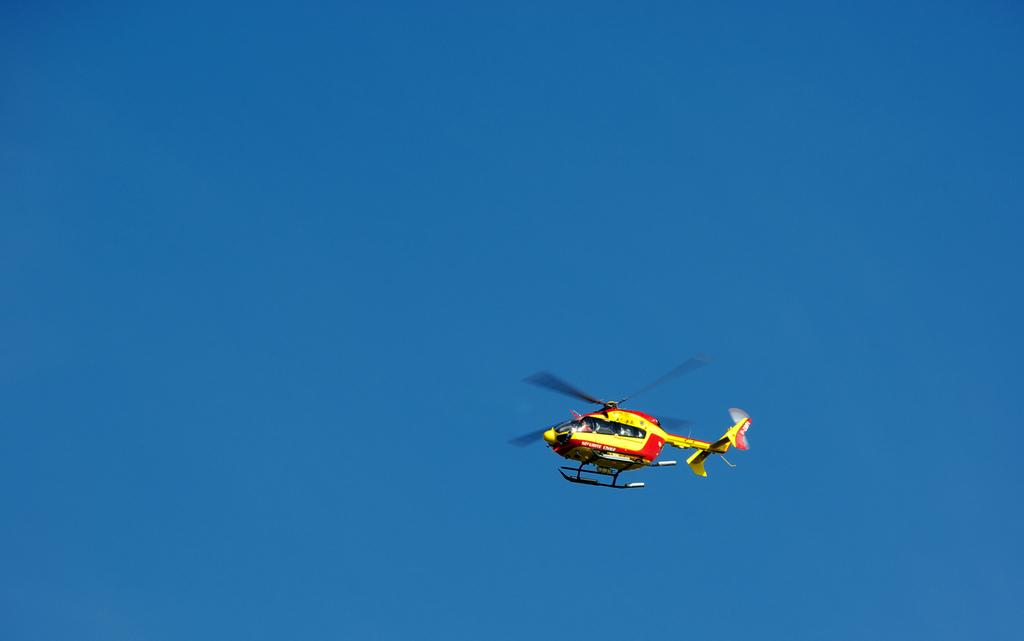What is the main subject in the center of the image? There is a helicopter in the center of the image. What can be seen in the background of the image? There is sky visible in the background of the image. What type of skin condition is visible on the helicopter in the image? There is no skin condition visible on the helicopter in the image, as helicopters do not have skin. 